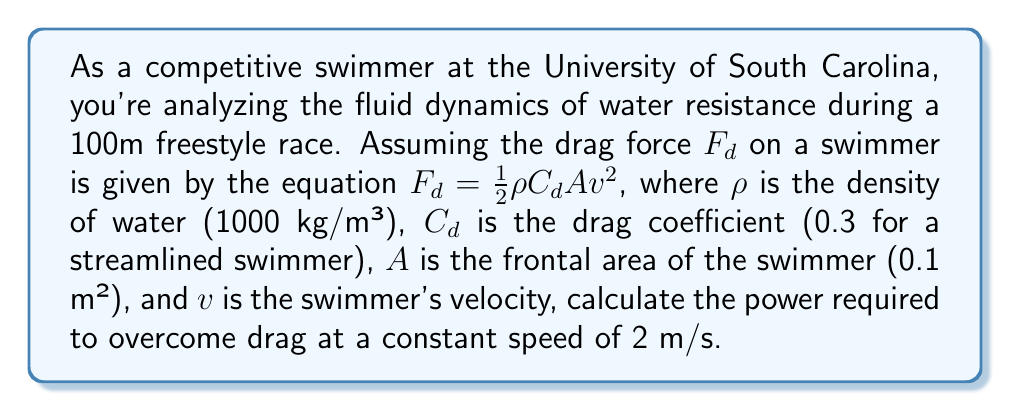Can you solve this math problem? To solve this problem, we'll follow these steps:

1. Identify the given values:
   $\rho = 1000$ kg/m³
   $C_d = 0.3$
   $A = 0.1$ m²
   $v = 2$ m/s

2. Calculate the drag force using the given equation:
   $$F_d = \frac{1}{2}\rho C_d A v^2$$
   $$F_d = \frac{1}{2} \cdot 1000 \cdot 0.3 \cdot 0.1 \cdot 2^2$$
   $$F_d = 60 \text{ N}$$

3. Calculate the power required to overcome drag:
   Power is defined as the rate of work done, which is equal to the force multiplied by velocity:
   $$P = F_d \cdot v$$
   $$P = 60 \cdot 2$$
   $$P = 120 \text{ W}$$

Therefore, the power required to overcome drag at a constant speed of 2 m/s is 120 watts.
Answer: 120 W 